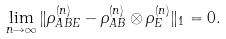<formula> <loc_0><loc_0><loc_500><loc_500>\lim _ { n \rightarrow \infty } \| \rho ^ { ( n ) } _ { A B E } - \rho ^ { ( n ) } _ { A B } \otimes \rho ^ { ( n ) } _ { E } \| _ { 1 } = 0 .</formula> 